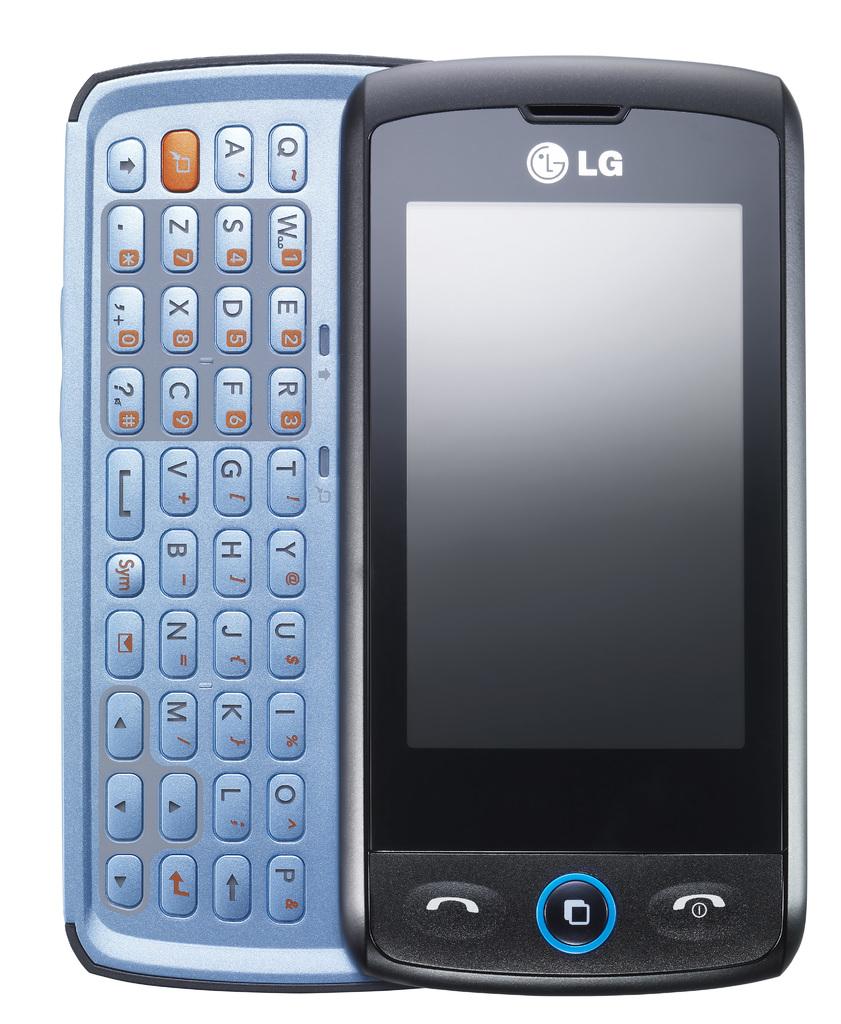What kind of phone is this?
Offer a very short reply. Lg. What is the brand of this phone?
Make the answer very short. Lg. 